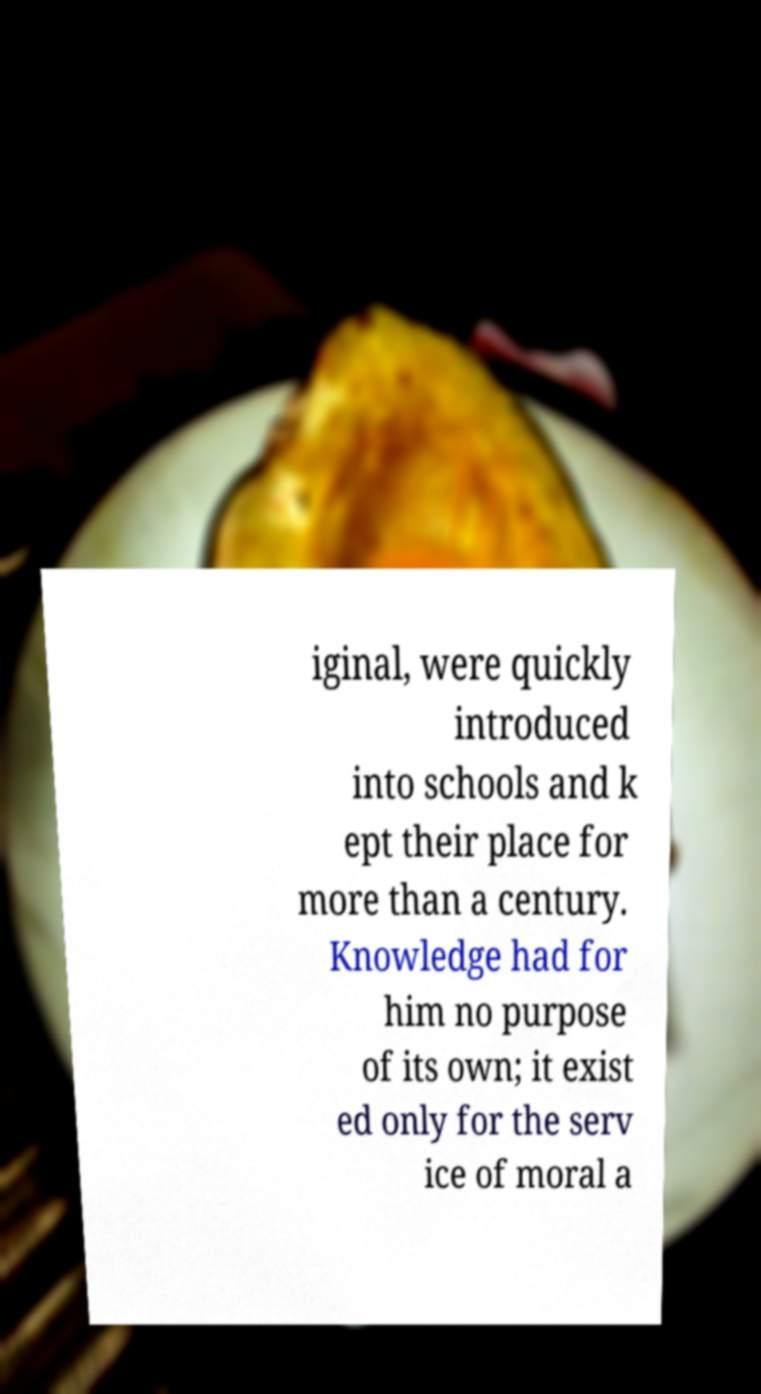Can you accurately transcribe the text from the provided image for me? iginal, were quickly introduced into schools and k ept their place for more than a century. Knowledge had for him no purpose of its own; it exist ed only for the serv ice of moral a 